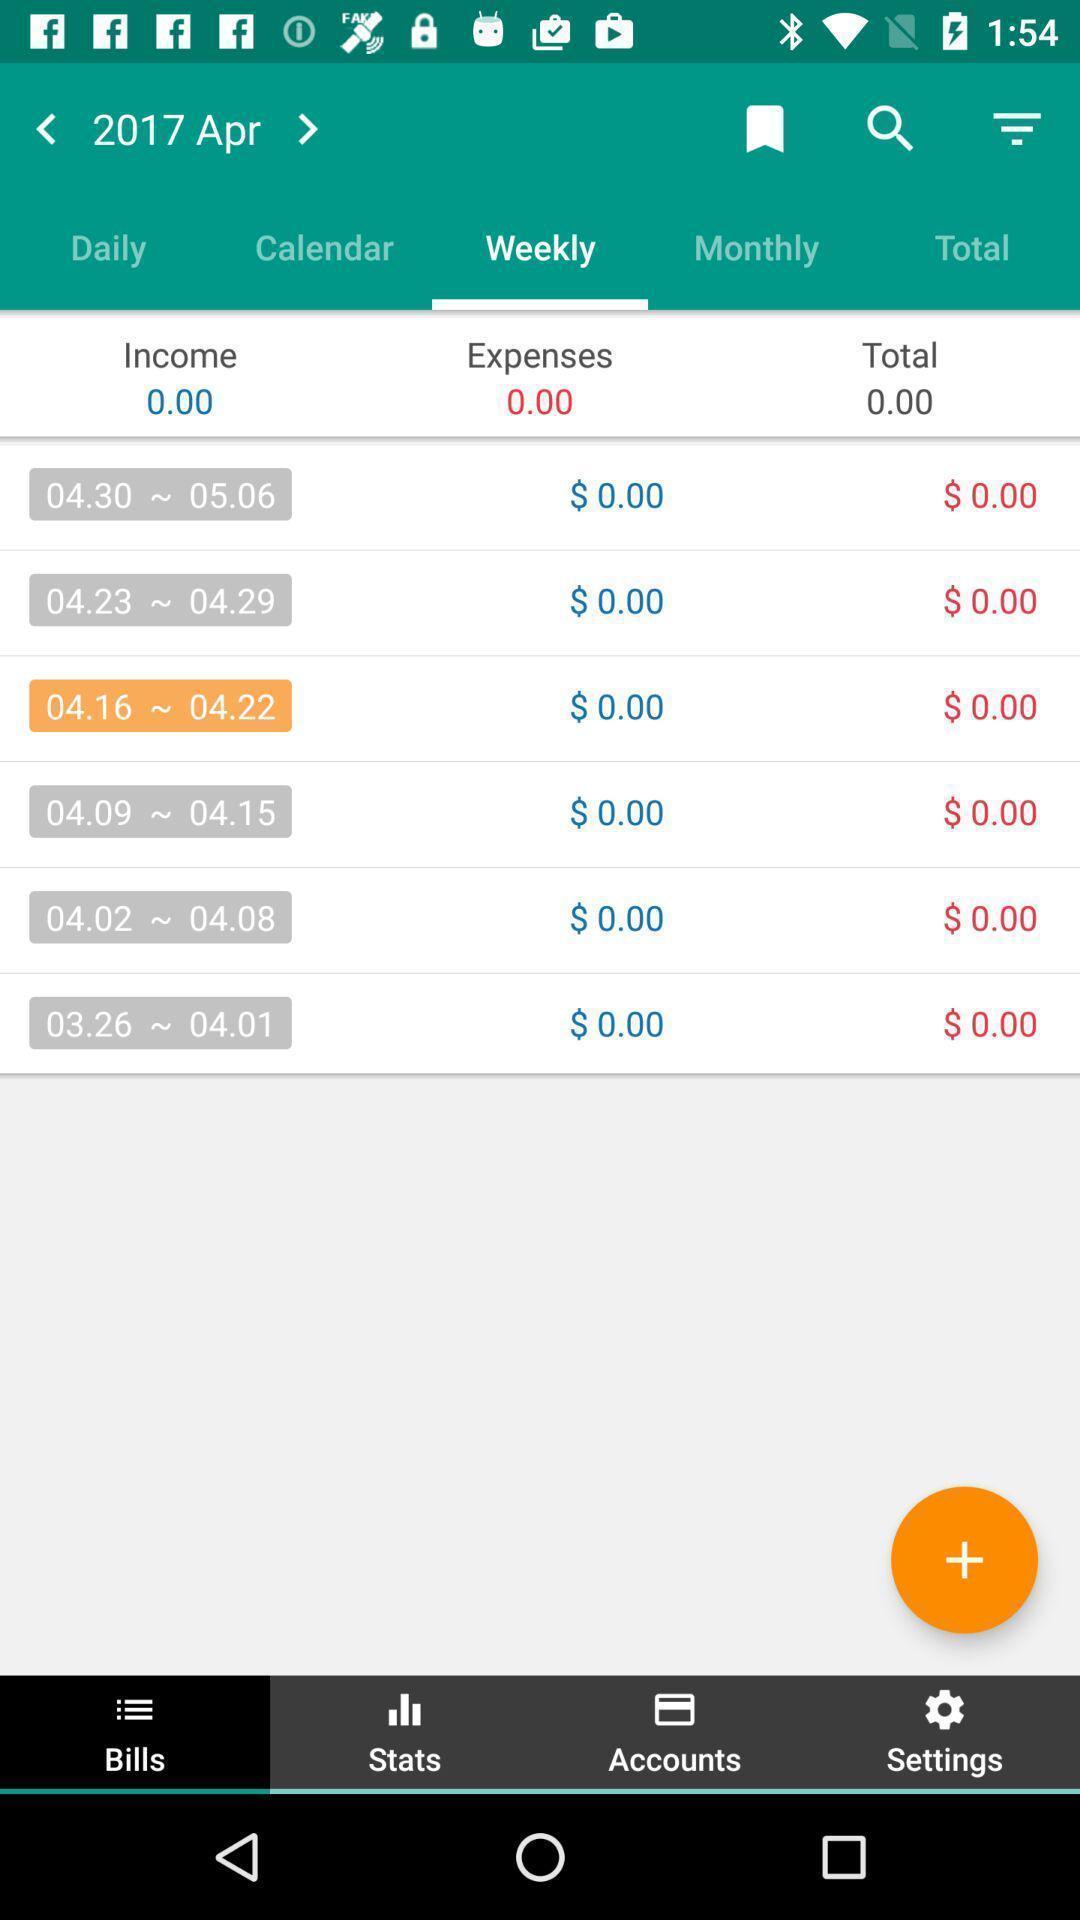Please provide a description for this image. Screen displaying multiple options in finance application. 